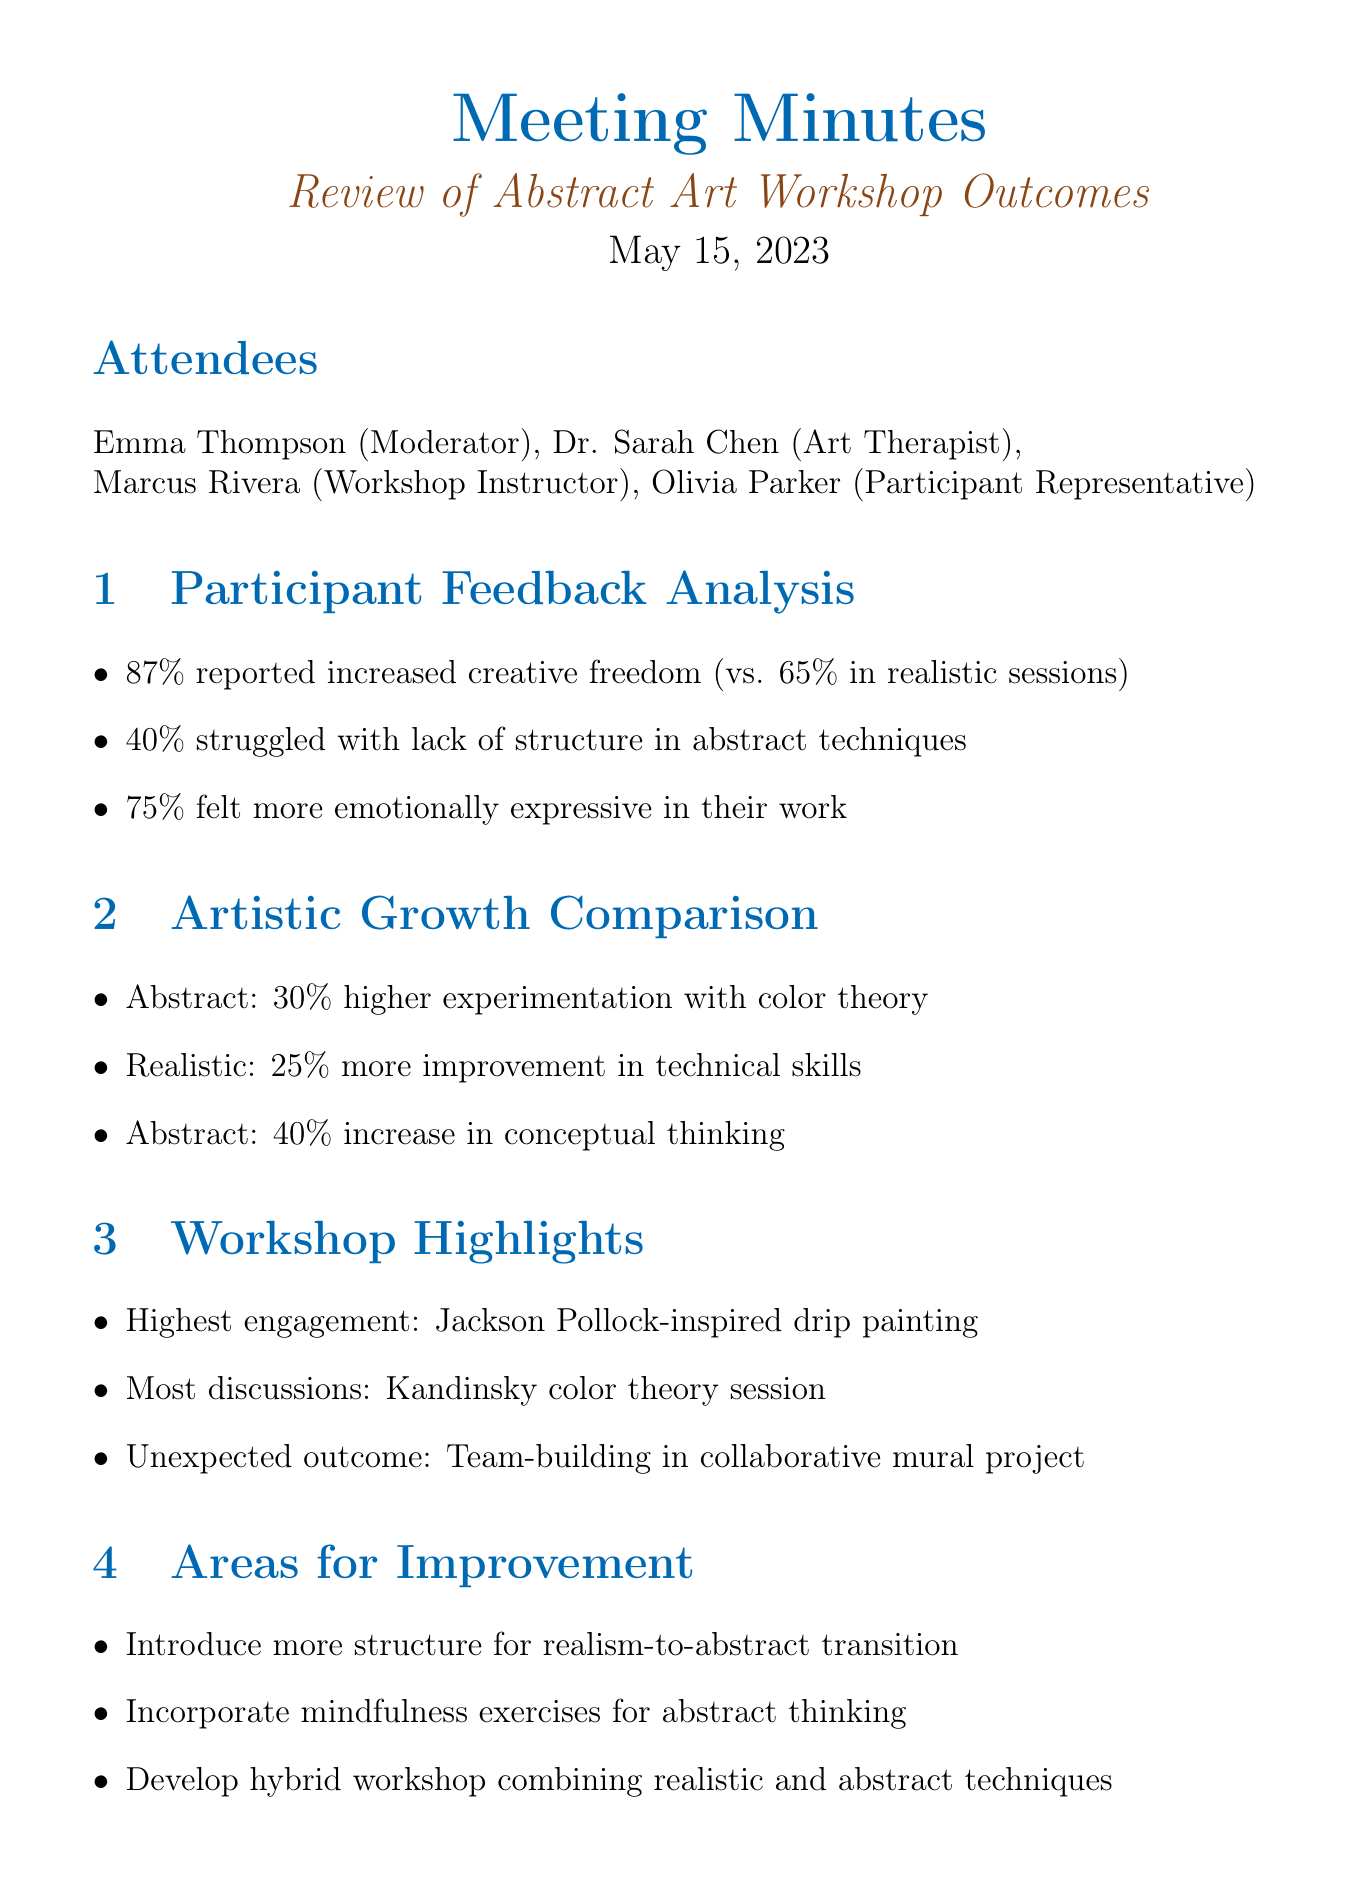What was the date of the meeting? The date of the meeting is stated at the top of the document.
Answer: May 15, 2023 Who was the workshop instructor? The name of the workshop instructor is listed in the attendees section.
Answer: Marcus Rivera What percentage of participants reported increased creative freedom in the abstract workshop? This information is found in the Participant Feedback Analysis section.
Answer: 87% Which art movement inspired the highest engagement exercise? The name of the art movement is mentioned in the Workshop Highlights section.
Answer: Jackson Pollock What was the area for improvement suggested for participants transitioning from realism? This suggestion is noted in the Areas for Improvement section.
Answer: Introduce more structure How much higher was experimentation with color theory in the abstract workshop compared to realistic sessions? This comparison is detailed in the Artistic Growth Comparison section.
Answer: 30% What is scheduled to happen in three months after the meeting? The next step involving future action is specified in the Next Steps section.
Answer: Follow-up survey What was one unexpected outcome from the collaborative mural project? The document mentions an unexpected result under Workshop Highlights.
Answer: Team-building What session sparked the most post-workshop discussions? This detail is provided in the Workshop Highlights section.
Answer: Kandinsky color theory session 